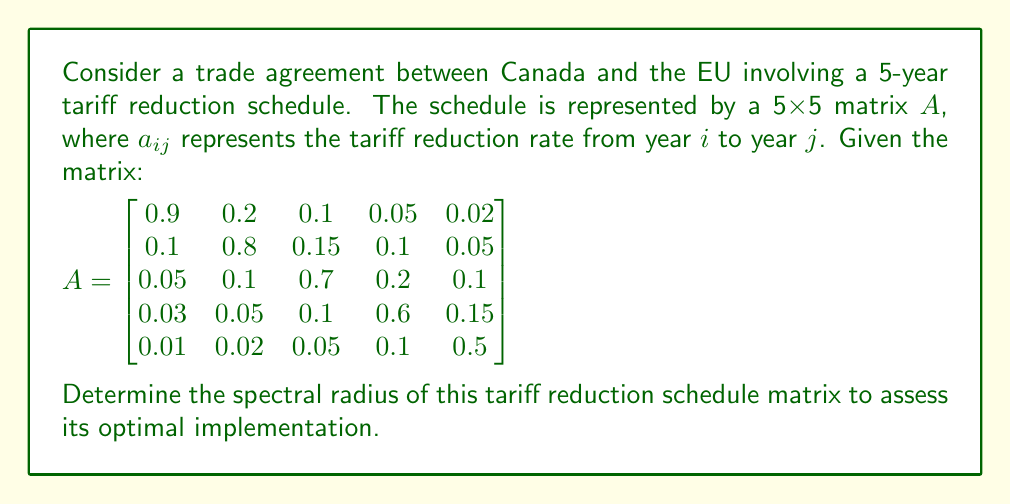Could you help me with this problem? To find the spectral radius of matrix A, we need to follow these steps:

1) First, we need to find the eigenvalues of matrix A. The characteristic equation is:

   $det(A - \lambda I) = 0$

2) Expanding this determinant gives us a 5th degree polynomial. Due to the complexity, we'll use a numerical method to approximate the eigenvalues.

3) Using a computer algebra system or numerical methods, we find the eigenvalues to be approximately:

   $\lambda_1 \approx 0.9053$
   $\lambda_2 \approx 0.7947 + 0.0318i$
   $\lambda_3 \approx 0.7947 - 0.0318i$
   $\lambda_4 \approx 0.5527 + 0.0447i$
   $\lambda_5 \approx 0.5527 - 0.0447i$

4) The spectral radius $\rho(A)$ is defined as the maximum of the absolute values of the eigenvalues:

   $\rho(A) = \max_{1 \leq i \leq 5} |\lambda_i|$

5) Computing the absolute values:

   $|\lambda_1| \approx 0.9053$
   $|\lambda_2| = |\lambda_3| \approx \sqrt{0.7947^2 + 0.0318^2} \approx 0.7953$
   $|\lambda_4| = |\lambda_5| \approx \sqrt{0.5527^2 + 0.0447^2} \approx 0.5545$

6) The maximum of these values is $|\lambda_1| \approx 0.9053$.

Therefore, the spectral radius of the tariff reduction schedule matrix is approximately 0.9053.
Answer: $\rho(A) \approx 0.9053$ 